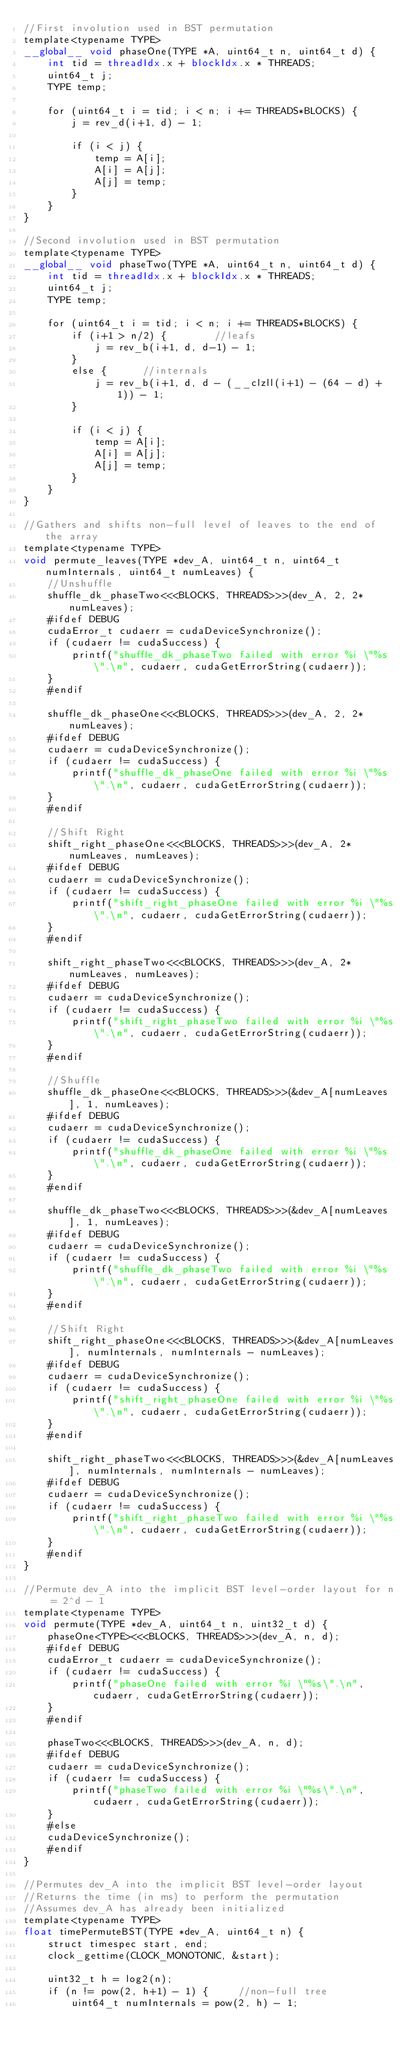Convert code to text. <code><loc_0><loc_0><loc_500><loc_500><_Cuda_>//First involution used in BST permutation
template<typename TYPE>
__global__ void phaseOne(TYPE *A, uint64_t n, uint64_t d) {
    int tid = threadIdx.x + blockIdx.x * THREADS;
    uint64_t j;
    TYPE temp;

    for (uint64_t i = tid; i < n; i += THREADS*BLOCKS) {
        j = rev_d(i+1, d) - 1;

        if (i < j) {
            temp = A[i];
            A[i] = A[j];
            A[j] = temp;
        }
    }
}

//Second involution used in BST permutation
template<typename TYPE>
__global__ void phaseTwo(TYPE *A, uint64_t n, uint64_t d) {
    int tid = threadIdx.x + blockIdx.x * THREADS;
    uint64_t j;
    TYPE temp;

    for (uint64_t i = tid; i < n; i += THREADS*BLOCKS) {
        if (i+1 > n/2) {        //leafs
            j = rev_b(i+1, d, d-1) - 1;
        }
        else {      //internals
            j = rev_b(i+1, d, d - (__clzll(i+1) - (64 - d) + 1)) - 1;
        }

        if (i < j) {
            temp = A[i];
            A[i] = A[j];
            A[j] = temp;
        }
    }
}

//Gathers and shifts non-full level of leaves to the end of the array
template<typename TYPE>
void permute_leaves(TYPE *dev_A, uint64_t n, uint64_t numInternals, uint64_t numLeaves) {
    //Unshuffle
    shuffle_dk_phaseTwo<<<BLOCKS, THREADS>>>(dev_A, 2, 2*numLeaves);
    #ifdef DEBUG
    cudaError_t cudaerr = cudaDeviceSynchronize();
    if (cudaerr != cudaSuccess) {
        printf("shuffle_dk_phaseTwo failed with error %i \"%s\".\n", cudaerr, cudaGetErrorString(cudaerr));
    }
    #endif

    shuffle_dk_phaseOne<<<BLOCKS, THREADS>>>(dev_A, 2, 2*numLeaves);
    #ifdef DEBUG
    cudaerr = cudaDeviceSynchronize();
    if (cudaerr != cudaSuccess) {
        printf("shuffle_dk_phaseOne failed with error %i \"%s\".\n", cudaerr, cudaGetErrorString(cudaerr));
    }
    #endif

    //Shift Right
    shift_right_phaseOne<<<BLOCKS, THREADS>>>(dev_A, 2*numLeaves, numLeaves);
    #ifdef DEBUG
    cudaerr = cudaDeviceSynchronize();
    if (cudaerr != cudaSuccess) {
        printf("shift_right_phaseOne failed with error %i \"%s\".\n", cudaerr, cudaGetErrorString(cudaerr));
    }
    #endif

    shift_right_phaseTwo<<<BLOCKS, THREADS>>>(dev_A, 2*numLeaves, numLeaves);
    #ifdef DEBUG
    cudaerr = cudaDeviceSynchronize();
    if (cudaerr != cudaSuccess) {
        printf("shift_right_phaseTwo failed with error %i \"%s\".\n", cudaerr, cudaGetErrorString(cudaerr));
    }
    #endif

    //Shuffle
    shuffle_dk_phaseOne<<<BLOCKS, THREADS>>>(&dev_A[numLeaves], 1, numLeaves);
    #ifdef DEBUG
    cudaerr = cudaDeviceSynchronize();
    if (cudaerr != cudaSuccess) {
        printf("shuffle_dk_phaseOne failed with error %i \"%s\".\n", cudaerr, cudaGetErrorString(cudaerr));
    }
    #endif

    shuffle_dk_phaseTwo<<<BLOCKS, THREADS>>>(&dev_A[numLeaves], 1, numLeaves);
    #ifdef DEBUG
    cudaerr = cudaDeviceSynchronize();
    if (cudaerr != cudaSuccess) {
        printf("shuffle_dk_phaseTwo failed with error %i \"%s\".\n", cudaerr, cudaGetErrorString(cudaerr));
    }
    #endif

    //Shift Right
    shift_right_phaseOne<<<BLOCKS, THREADS>>>(&dev_A[numLeaves], numInternals, numInternals - numLeaves);
    #ifdef DEBUG
    cudaerr = cudaDeviceSynchronize();
    if (cudaerr != cudaSuccess) {
        printf("shift_right_phaseOne failed with error %i \"%s\".\n", cudaerr, cudaGetErrorString(cudaerr));
    }
    #endif

    shift_right_phaseTwo<<<BLOCKS, THREADS>>>(&dev_A[numLeaves], numInternals, numInternals - numLeaves);
    #ifdef DEBUG
    cudaerr = cudaDeviceSynchronize();
    if (cudaerr != cudaSuccess) {
        printf("shift_right_phaseTwo failed with error %i \"%s\".\n", cudaerr, cudaGetErrorString(cudaerr));
    }
    #endif
}

//Permute dev_A into the implicit BST level-order layout for n = 2^d - 1
template<typename TYPE>
void permute(TYPE *dev_A, uint64_t n, uint32_t d) {
    phaseOne<TYPE><<<BLOCKS, THREADS>>>(dev_A, n, d);
    #ifdef DEBUG
    cudaError_t cudaerr = cudaDeviceSynchronize();
    if (cudaerr != cudaSuccess) {
        printf("phaseOne failed with error %i \"%s\".\n", cudaerr, cudaGetErrorString(cudaerr));
    }
    #endif

    phaseTwo<<<BLOCKS, THREADS>>>(dev_A, n, d);
    #ifdef DEBUG
    cudaerr = cudaDeviceSynchronize();
    if (cudaerr != cudaSuccess) {
        printf("phaseTwo failed with error %i \"%s\".\n", cudaerr, cudaGetErrorString(cudaerr));
    }
    #else
    cudaDeviceSynchronize();
    #endif
}

//Permutes dev_A into the implicit BST level-order layout 
//Returns the time (in ms) to perform the permutation
//Assumes dev_A has already been initialized
template<typename TYPE>
float timePermuteBST(TYPE *dev_A, uint64_t n) {
    struct timespec start, end;
    clock_gettime(CLOCK_MONOTONIC, &start);

    uint32_t h = log2(n);
    if (n != pow(2, h+1) - 1) {     //non-full tree
        uint64_t numInternals = pow(2, h) - 1;</code> 